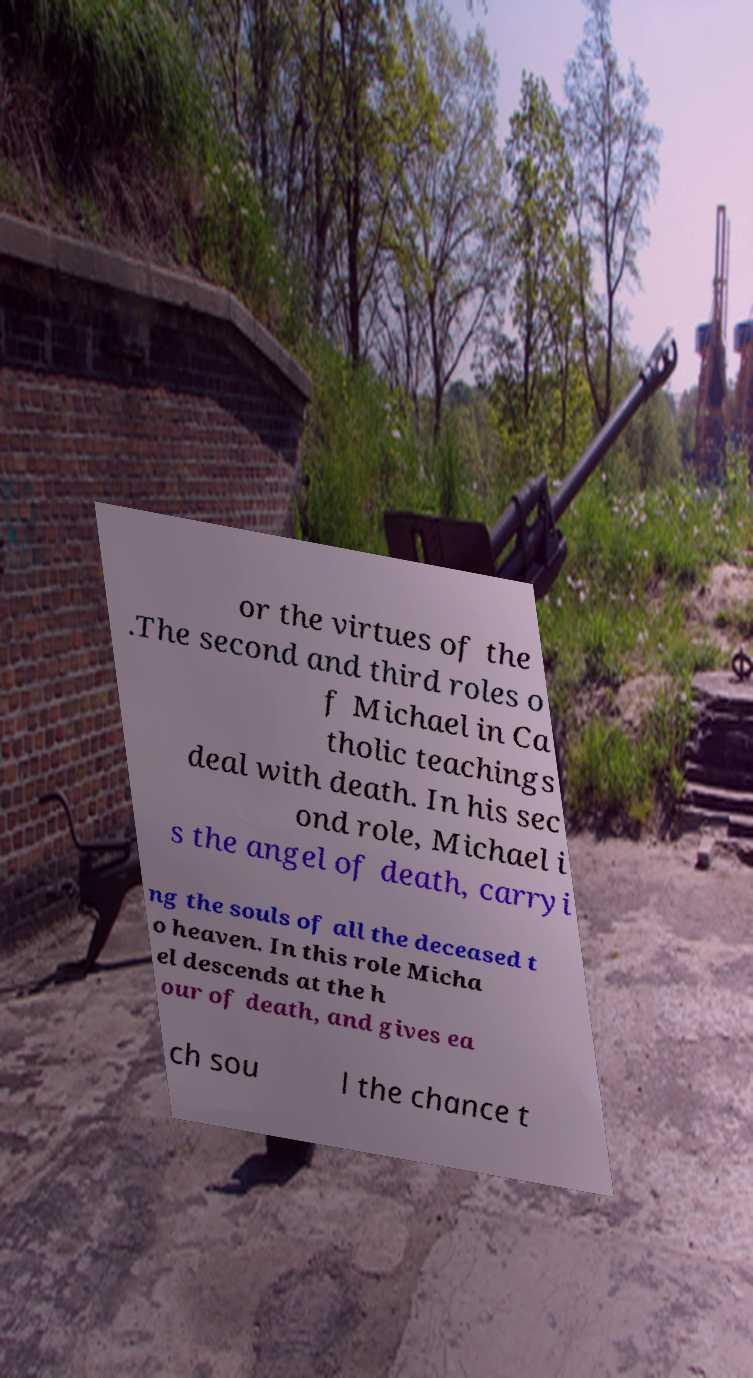Could you assist in decoding the text presented in this image and type it out clearly? or the virtues of the .The second and third roles o f Michael in Ca tholic teachings deal with death. In his sec ond role, Michael i s the angel of death, carryi ng the souls of all the deceased t o heaven. In this role Micha el descends at the h our of death, and gives ea ch sou l the chance t 